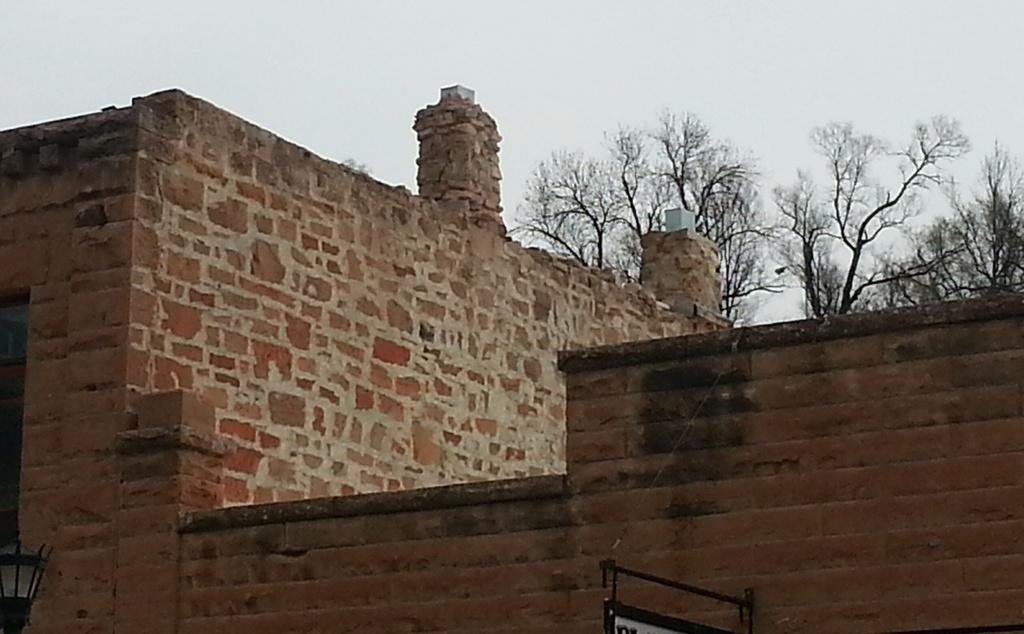What is one of the main features of the image? There is a wall in the image. What can be seen in the background of the image? The sky is visible in the image. What type of vegetation is present in the image? There is a tree at the top of the image. Where is the light located in the image? A light is visible in the bottom left of the image. Can you see the smile on the tree in the image? There is no smile present on the tree in the image, as trees do not have facial expressions. 